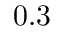<formula> <loc_0><loc_0><loc_500><loc_500>0 . 3</formula> 